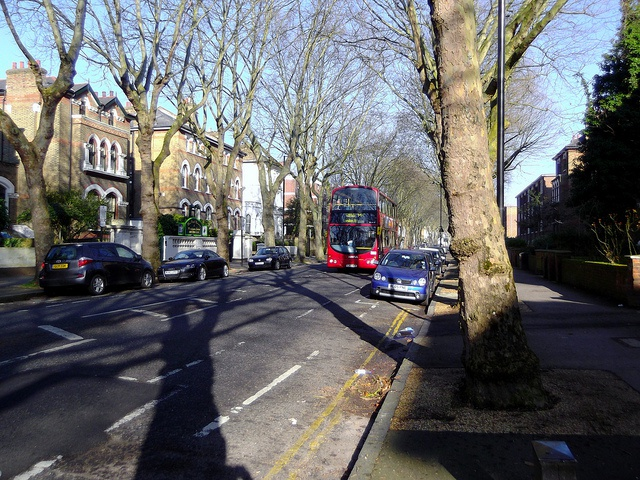Describe the objects in this image and their specific colors. I can see bus in purple, black, gray, navy, and maroon tones, car in purple, black, navy, gray, and darkblue tones, car in purple, blue, gray, navy, and black tones, car in purple, black, navy, gray, and darkgray tones, and car in purple, black, gray, and navy tones in this image. 